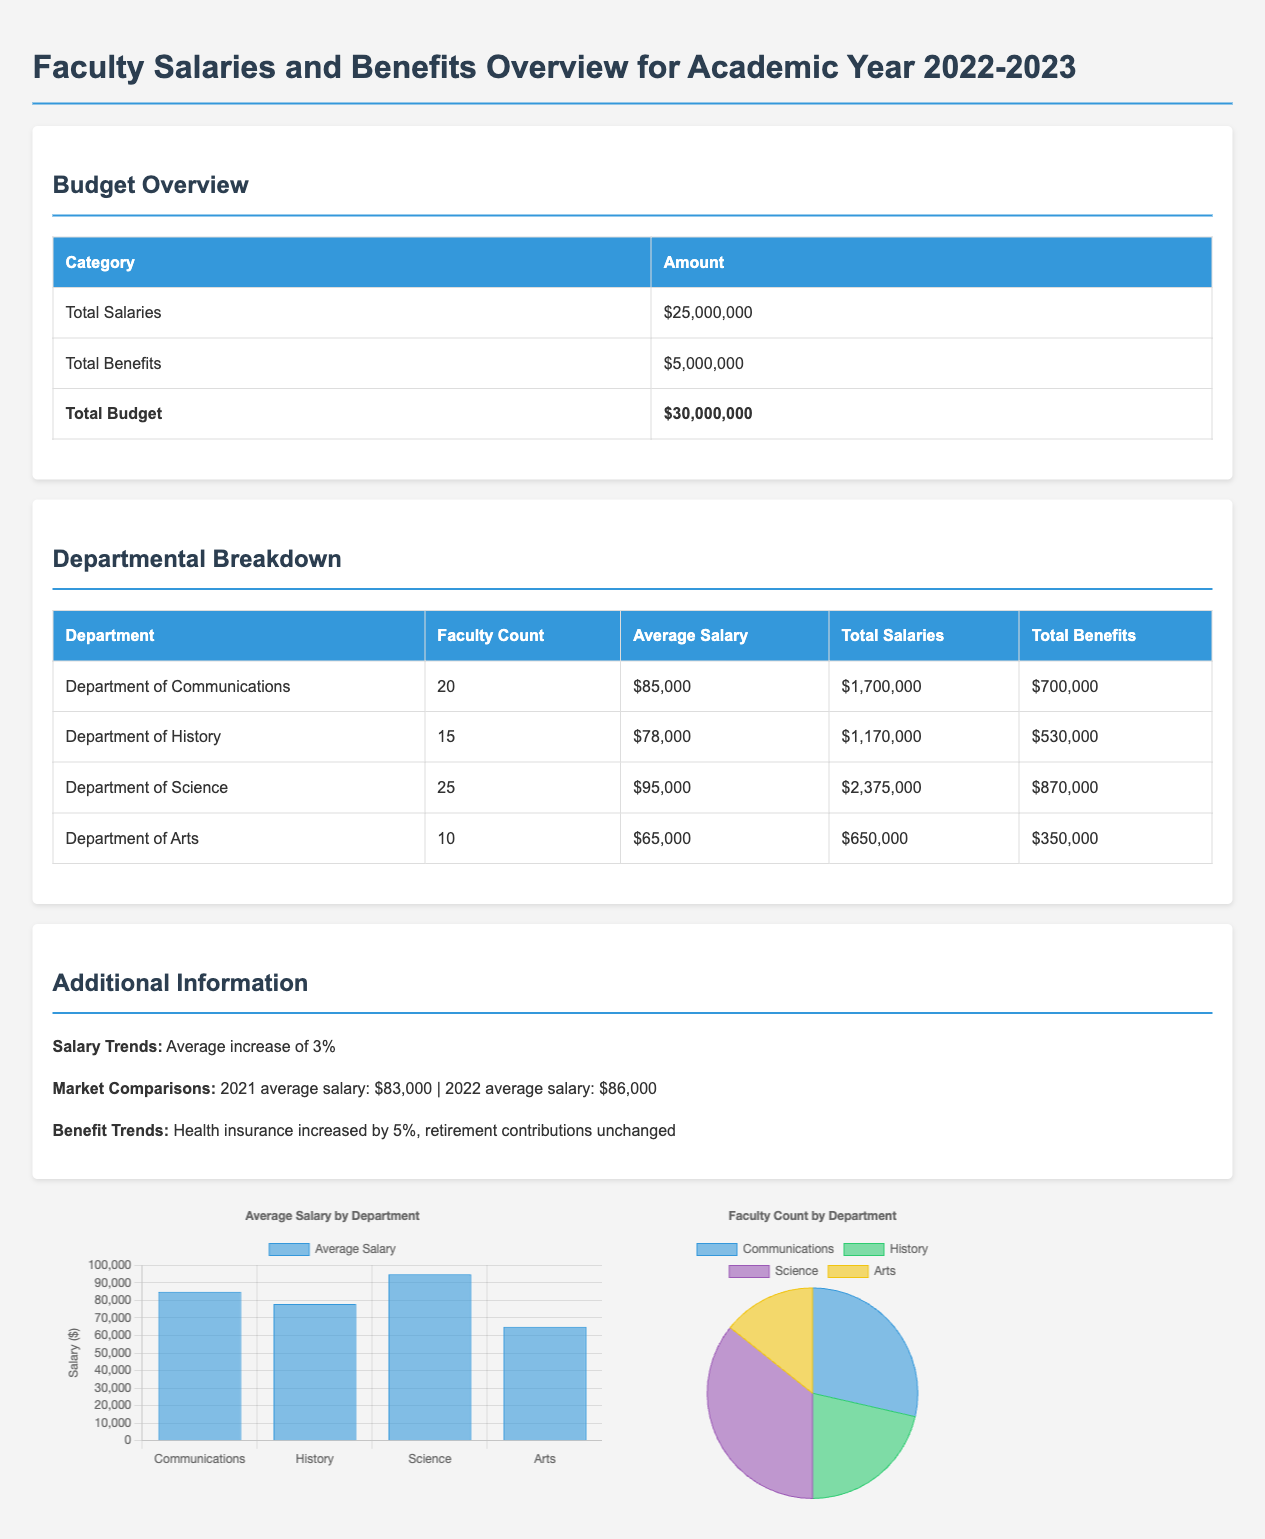What is the total budget? The total budget is the sum of the total salaries and total benefits in the document, which is $25,000,000 + $5,000,000 = $30,000,000.
Answer: $30,000,000 How many faculty members are in the Department of Science? The document states that the Department of Science has a faculty count of 25.
Answer: 25 What is the average salary in the Department of Arts? The average salary for the Department of Arts, as shown in the table, is $65,000.
Answer: $65,000 What is the total amount allocated for benefits? The total benefits listed in the overview section of the document is $5,000,000.
Answer: $5,000,000 What department has the highest average salary? The department with the highest average salary, based on the provided data, is the Department of Science.
Answer: Science What was the average salary increase percentage? The document notes an average increase of 3% in salaries.
Answer: 3% What is the total salary amount for the Department of Communications? The total salaries for the Department of Communications listed in the document is $1,700,000.
Answer: $1,700,000 Which department has the lowest total benefits? The department with the lowest total benefits is the Department of Arts with $350,000.
Answer: Arts How many total departments are listed in the document? The document includes four distinct departments: Communications, History, Science, and Arts.
Answer: 4 